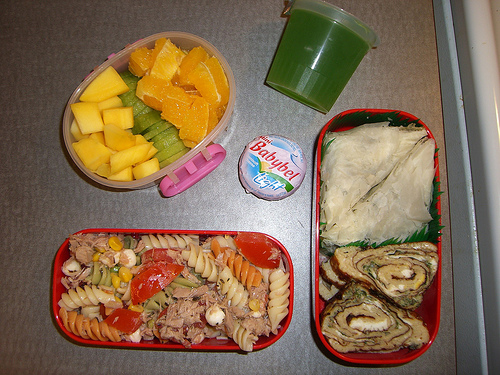<image>
Can you confirm if the pasta is in the container? No. The pasta is not contained within the container. These objects have a different spatial relationship. 